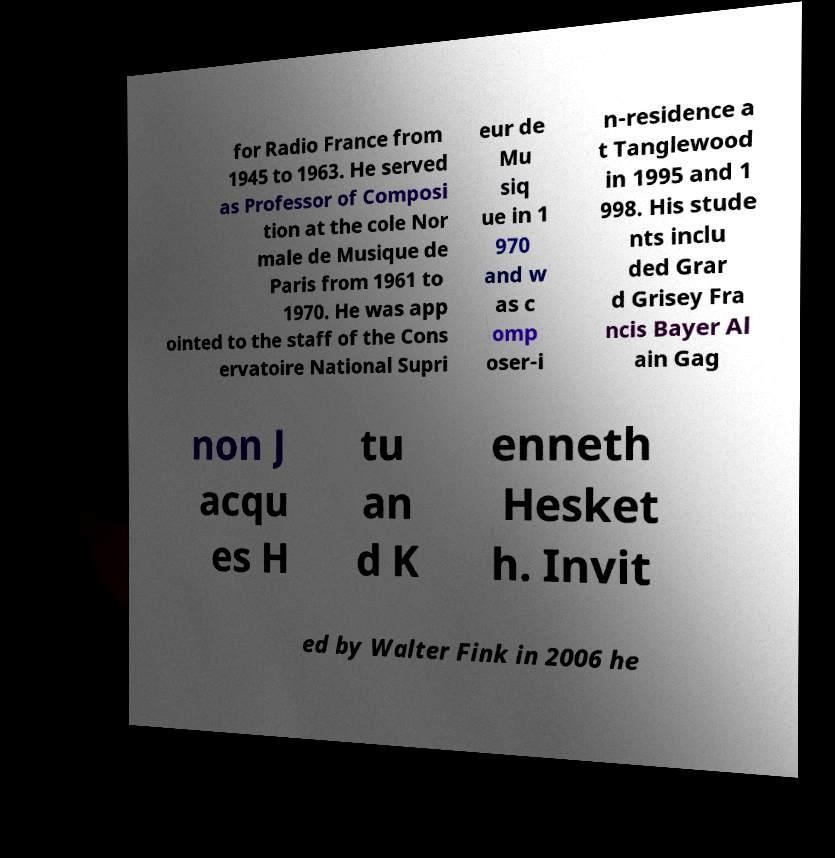Could you extract and type out the text from this image? for Radio France from 1945 to 1963. He served as Professor of Composi tion at the cole Nor male de Musique de Paris from 1961 to 1970. He was app ointed to the staff of the Cons ervatoire National Supri eur de Mu siq ue in 1 970 and w as c omp oser-i n-residence a t Tanglewood in 1995 and 1 998. His stude nts inclu ded Grar d Grisey Fra ncis Bayer Al ain Gag non J acqu es H tu an d K enneth Hesket h. Invit ed by Walter Fink in 2006 he 